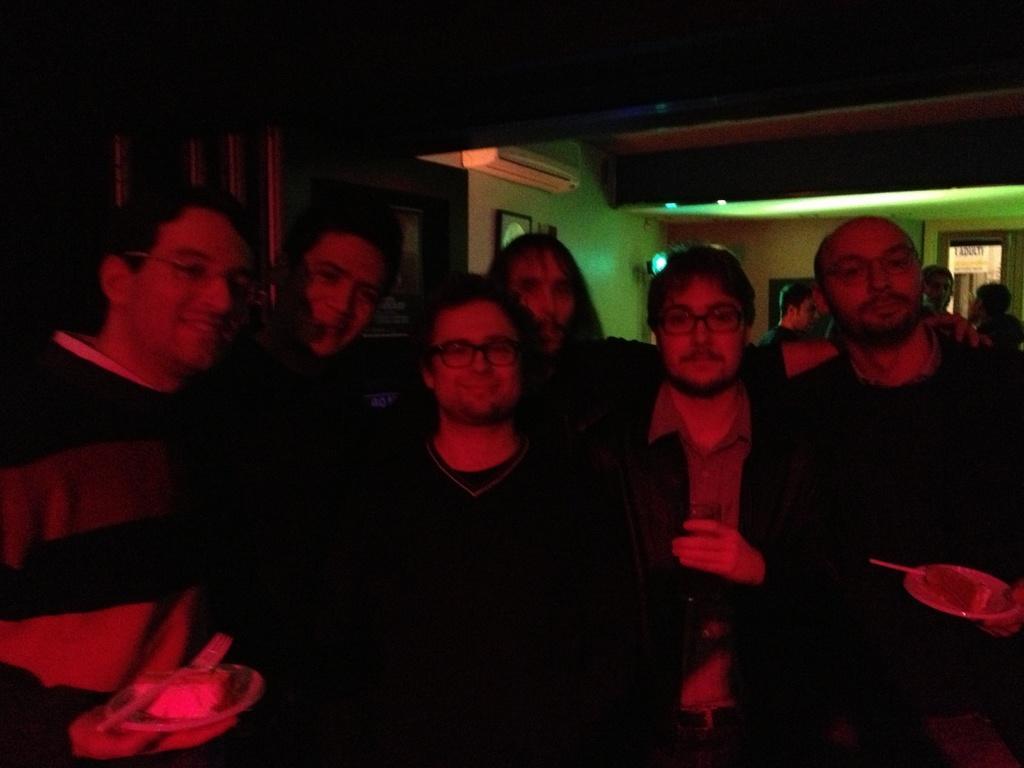Please provide a concise description of this image. In front of the image there is a group of people standing with a smile on their face, some of them are holding some objects in their hands, behind them there are a few other people, in the background of the image there are photo frames, lamps, air conditioners on the wall. 